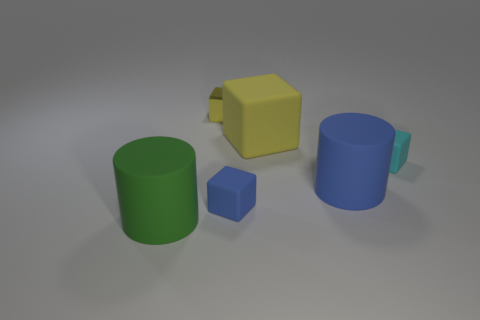There is a big green matte thing in front of the blue cylinder; is its shape the same as the yellow matte thing?
Provide a short and direct response. No. What size is the shiny thing that is the same color as the large rubber block?
Your answer should be compact. Small. Is there another object that has the same size as the yellow matte thing?
Your response must be concise. Yes. There is a blue matte object left of the rubber cylinder on the right side of the green rubber cylinder; are there any small cyan matte things that are left of it?
Make the answer very short. No. Does the metal object have the same color as the large matte cylinder that is on the left side of the small metallic object?
Your answer should be compact. No. The large thing that is behind the rubber thing that is right of the large matte cylinder that is right of the large block is made of what material?
Your answer should be very brief. Rubber. What shape is the thing in front of the blue block?
Provide a succinct answer. Cylinder. What is the size of the green cylinder that is the same material as the cyan object?
Make the answer very short. Large. What number of other small metallic things have the same shape as the small yellow metal thing?
Offer a very short reply. 0. There is a matte block to the right of the blue rubber cylinder; is it the same color as the small shiny object?
Give a very brief answer. No. 